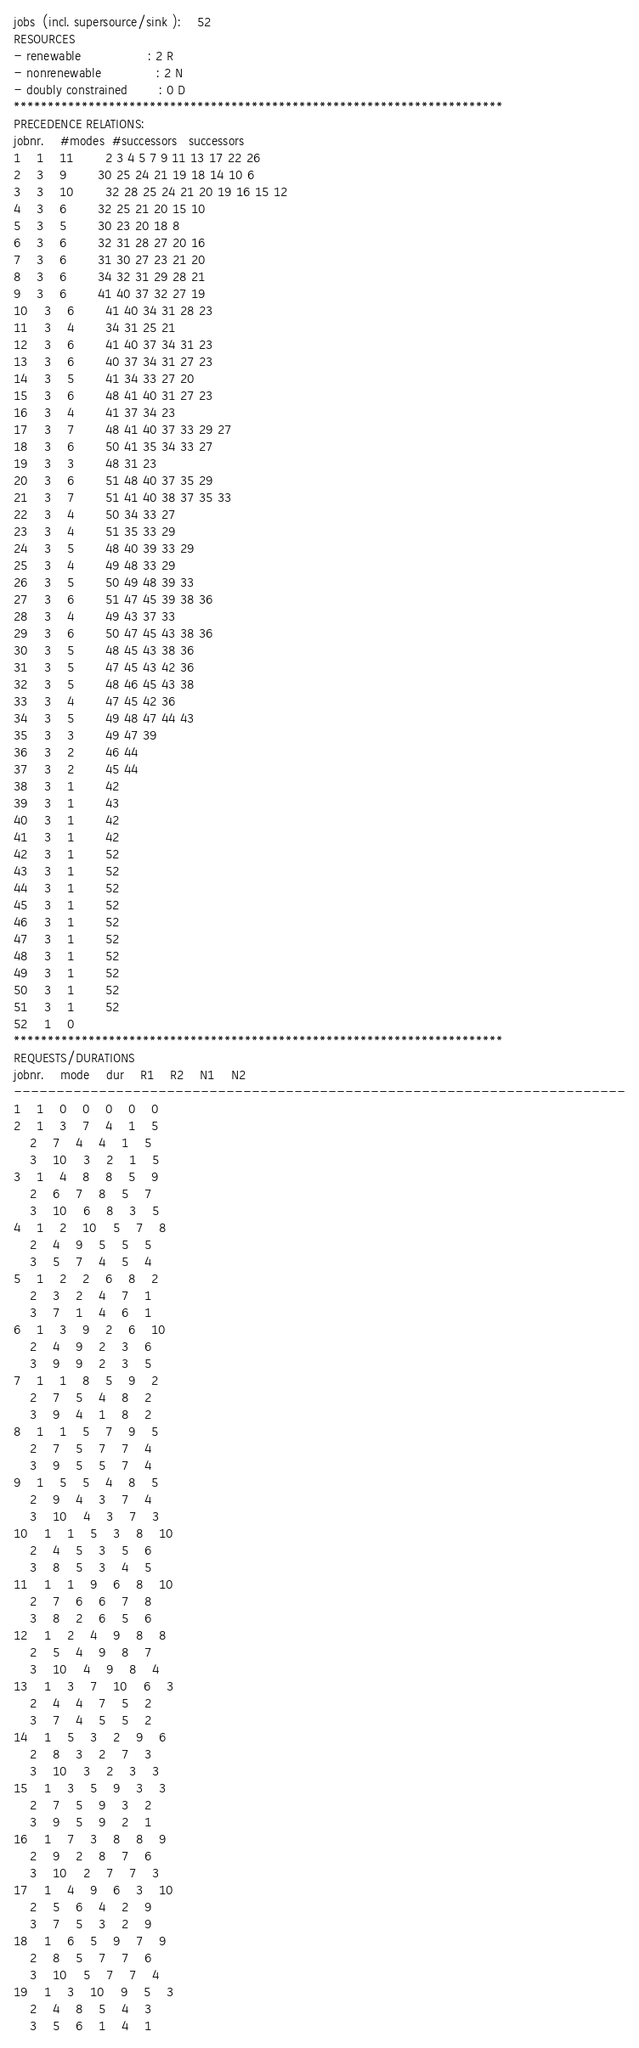<code> <loc_0><loc_0><loc_500><loc_500><_ObjectiveC_>jobs  (incl. supersource/sink ):	52
RESOURCES
- renewable                 : 2 R
- nonrenewable              : 2 N
- doubly constrained        : 0 D
************************************************************************
PRECEDENCE RELATIONS:
jobnr.    #modes  #successors   successors
1	1	11		2 3 4 5 7 9 11 13 17 22 26 
2	3	9		30 25 24 21 19 18 14 10 6 
3	3	10		32 28 25 24 21 20 19 16 15 12 
4	3	6		32 25 21 20 15 10 
5	3	5		30 23 20 18 8 
6	3	6		32 31 28 27 20 16 
7	3	6		31 30 27 23 21 20 
8	3	6		34 32 31 29 28 21 
9	3	6		41 40 37 32 27 19 
10	3	6		41 40 34 31 28 23 
11	3	4		34 31 25 21 
12	3	6		41 40 37 34 31 23 
13	3	6		40 37 34 31 27 23 
14	3	5		41 34 33 27 20 
15	3	6		48 41 40 31 27 23 
16	3	4		41 37 34 23 
17	3	7		48 41 40 37 33 29 27 
18	3	6		50 41 35 34 33 27 
19	3	3		48 31 23 
20	3	6		51 48 40 37 35 29 
21	3	7		51 41 40 38 37 35 33 
22	3	4		50 34 33 27 
23	3	4		51 35 33 29 
24	3	5		48 40 39 33 29 
25	3	4		49 48 33 29 
26	3	5		50 49 48 39 33 
27	3	6		51 47 45 39 38 36 
28	3	4		49 43 37 33 
29	3	6		50 47 45 43 38 36 
30	3	5		48 45 43 38 36 
31	3	5		47 45 43 42 36 
32	3	5		48 46 45 43 38 
33	3	4		47 45 42 36 
34	3	5		49 48 47 44 43 
35	3	3		49 47 39 
36	3	2		46 44 
37	3	2		45 44 
38	3	1		42 
39	3	1		43 
40	3	1		42 
41	3	1		42 
42	3	1		52 
43	3	1		52 
44	3	1		52 
45	3	1		52 
46	3	1		52 
47	3	1		52 
48	3	1		52 
49	3	1		52 
50	3	1		52 
51	3	1		52 
52	1	0		
************************************************************************
REQUESTS/DURATIONS
jobnr.	mode	dur	R1	R2	N1	N2	
------------------------------------------------------------------------
1	1	0	0	0	0	0	
2	1	3	7	4	1	5	
	2	7	4	4	1	5	
	3	10	3	2	1	5	
3	1	4	8	8	5	9	
	2	6	7	8	5	7	
	3	10	6	8	3	5	
4	1	2	10	5	7	8	
	2	4	9	5	5	5	
	3	5	7	4	5	4	
5	1	2	2	6	8	2	
	2	3	2	4	7	1	
	3	7	1	4	6	1	
6	1	3	9	2	6	10	
	2	4	9	2	3	6	
	3	9	9	2	3	5	
7	1	1	8	5	9	2	
	2	7	5	4	8	2	
	3	9	4	1	8	2	
8	1	1	5	7	9	5	
	2	7	5	7	7	4	
	3	9	5	5	7	4	
9	1	5	5	4	8	5	
	2	9	4	3	7	4	
	3	10	4	3	7	3	
10	1	1	5	3	8	10	
	2	4	5	3	5	6	
	3	8	5	3	4	5	
11	1	1	9	6	8	10	
	2	7	6	6	7	8	
	3	8	2	6	5	6	
12	1	2	4	9	8	8	
	2	5	4	9	8	7	
	3	10	4	9	8	4	
13	1	3	7	10	6	3	
	2	4	4	7	5	2	
	3	7	4	5	5	2	
14	1	5	3	2	9	6	
	2	8	3	2	7	3	
	3	10	3	2	3	3	
15	1	3	5	9	3	3	
	2	7	5	9	3	2	
	3	9	5	9	2	1	
16	1	7	3	8	8	9	
	2	9	2	8	7	6	
	3	10	2	7	7	3	
17	1	4	9	6	3	10	
	2	5	6	4	2	9	
	3	7	5	3	2	9	
18	1	6	5	9	7	9	
	2	8	5	7	7	6	
	3	10	5	7	7	4	
19	1	3	10	9	5	3	
	2	4	8	5	4	3	
	3	5	6	1	4	1	</code> 